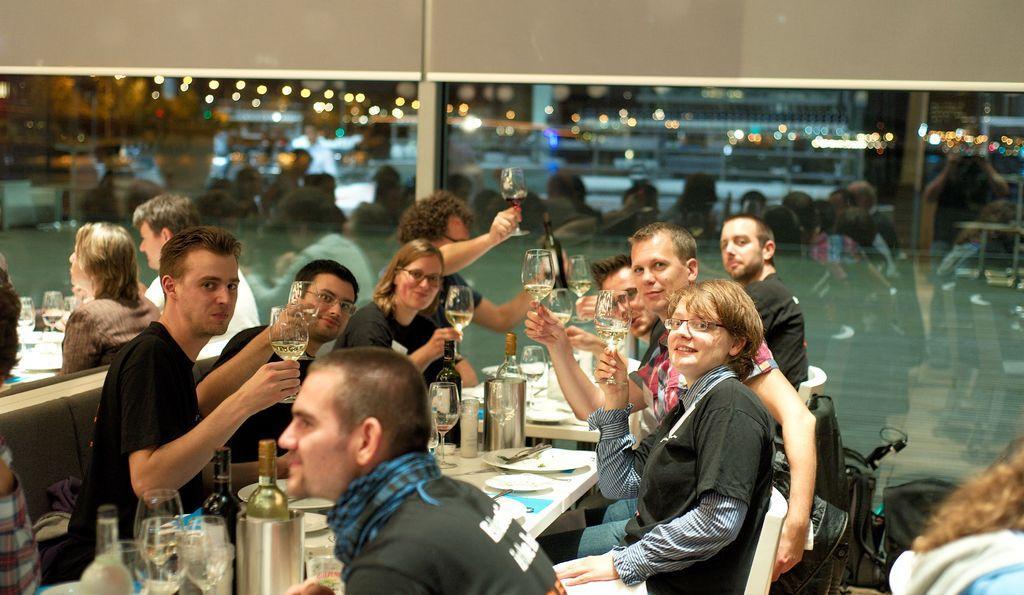Can you describe this image briefly? There are few persons sitting in chairs and holding a glass of wine in their hands and there is a table in front of them which has few eatables and some other objects placed on it. 